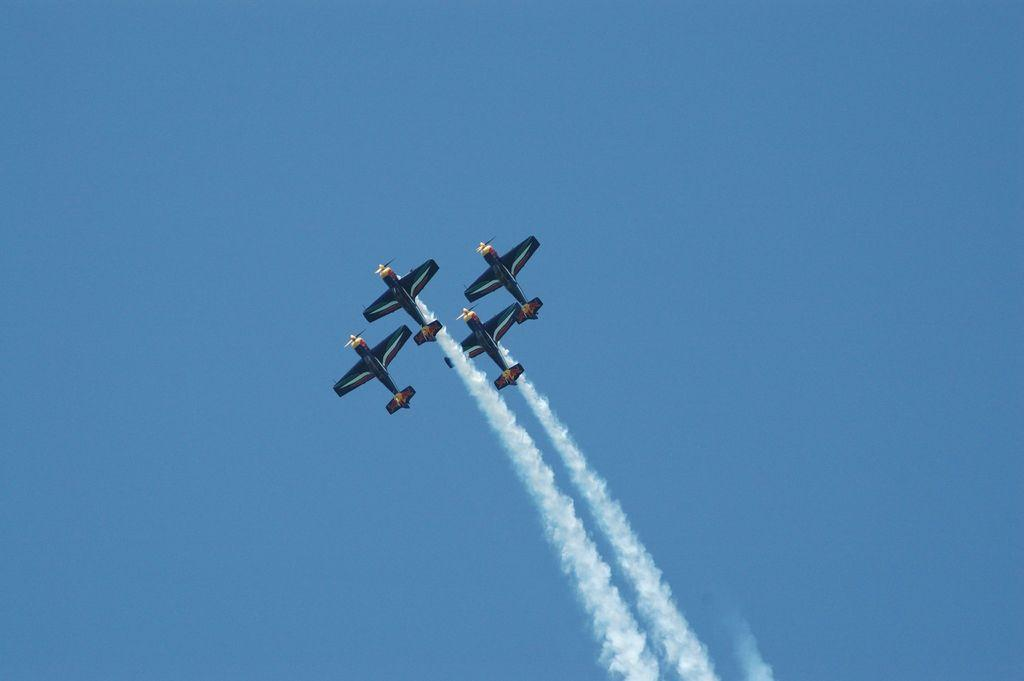How many flying jets can be seen in the image? There are four flying jets in the image. Where are the jets flying in the image? The jets are flying in the sky in the image. What else can be seen in the sky besides the jets? There is smoke visible in the image. What is the background of the image? The sky is visible in the image. What type of ship can be seen sailing in the image? There is no ship present in the image; it features four flying jets and smoke in the sky. 